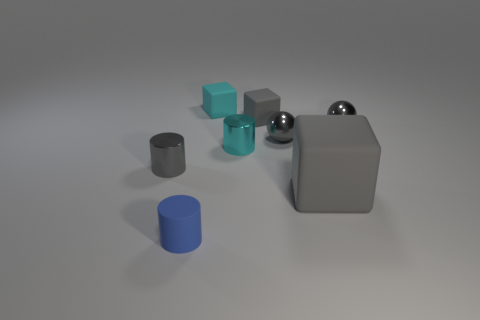Add 1 tiny cyan things. How many objects exist? 9 Subtract all spheres. How many objects are left? 6 Subtract 0 brown cylinders. How many objects are left? 8 Subtract all tiny purple matte cubes. Subtract all big gray rubber blocks. How many objects are left? 7 Add 3 small gray spheres. How many small gray spheres are left? 5 Add 1 blue things. How many blue things exist? 2 